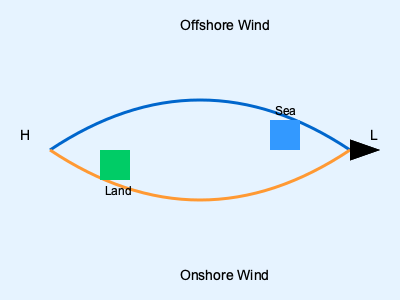As a seasoned sailor, you understand the importance of wind patterns in shaping surf conditions. Based on the weather map provided, which wind direction would likely create the best surfing conditions, and why would you recommend this to the local surf shop owner? 1. Analyze the weather map:
   - The map shows two wind patterns: offshore (blue) and onshore (orange).
   - "H" indicates a high-pressure area, while "L" indicates a low-pressure area.

2. Understand wind direction:
   - Offshore wind blows from land to sea (H to L).
   - Onshore wind blows from sea to land (L to H).

3. Effects on surf conditions:
   - Offshore winds:
     a) Create cleaner, more organized waves.
     b) Hold up the face of the wave, delaying breaking.
     c) Reduce chop on the water surface.
   - Onshore winds:
     a) Create messier, less organized waves.
     b) Cause waves to break prematurely.
     c) Increase chop on the water surface.

4. Impact on surfing:
   - Offshore winds generally produce better surfing conditions.
   - They allow surfers to ride longer, smoother waves.
   - The delayed breaking gives surfers more time to catch waves.

5. Recommendation to surf shop owner:
   - Advise customers to look for days with offshore winds.
   - Explain that these conditions often result in better surfing experiences.
   - Suggest monitoring weather patterns to predict good surf days.

6. Additional considerations:
   - Wind strength matters; gentle to moderate offshore winds are ideal.
   - Extremely strong offshore winds can make paddling difficult.
   - Local topography and bathymetry also influence wave quality.
Answer: Offshore winds create better surfing conditions due to cleaner, more organized waves with delayed breaking. 